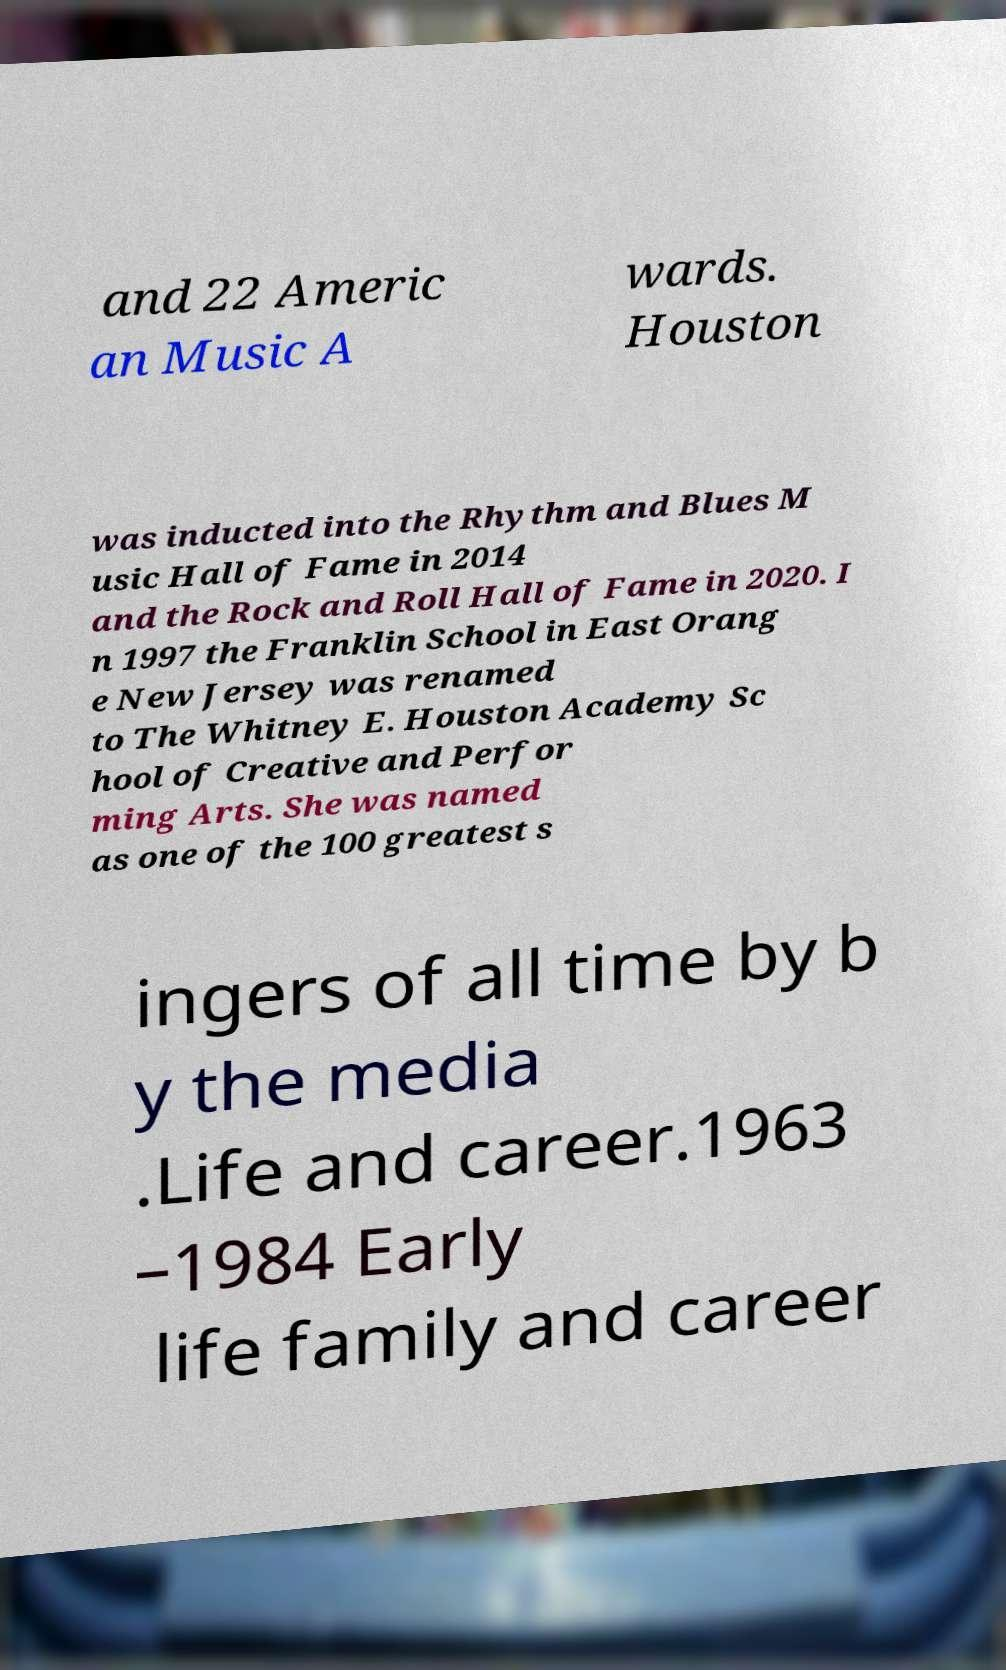There's text embedded in this image that I need extracted. Can you transcribe it verbatim? and 22 Americ an Music A wards. Houston was inducted into the Rhythm and Blues M usic Hall of Fame in 2014 and the Rock and Roll Hall of Fame in 2020. I n 1997 the Franklin School in East Orang e New Jersey was renamed to The Whitney E. Houston Academy Sc hool of Creative and Perfor ming Arts. She was named as one of the 100 greatest s ingers of all time by b y the media .Life and career.1963 –1984 Early life family and career 